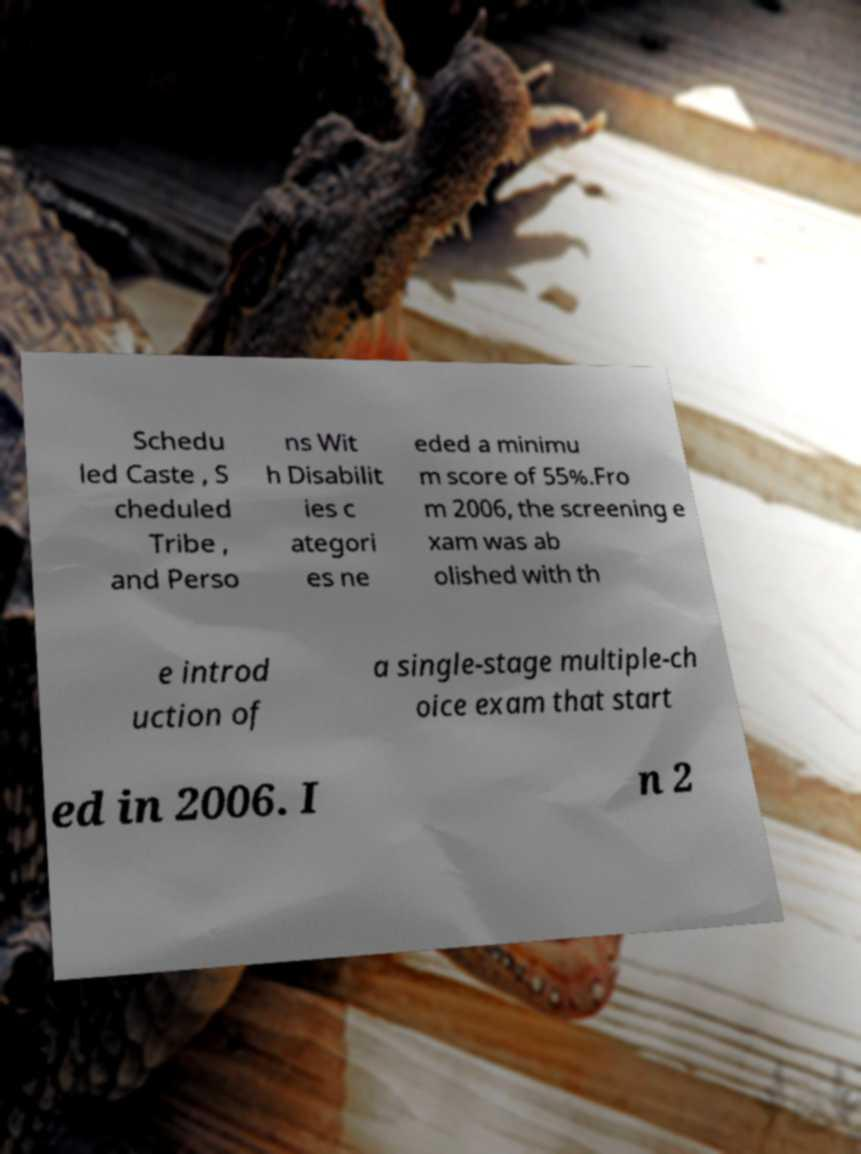Can you accurately transcribe the text from the provided image for me? Schedu led Caste , S cheduled Tribe , and Perso ns Wit h Disabilit ies c ategori es ne eded a minimu m score of 55%.Fro m 2006, the screening e xam was ab olished with th e introd uction of a single-stage multiple-ch oice exam that start ed in 2006. I n 2 